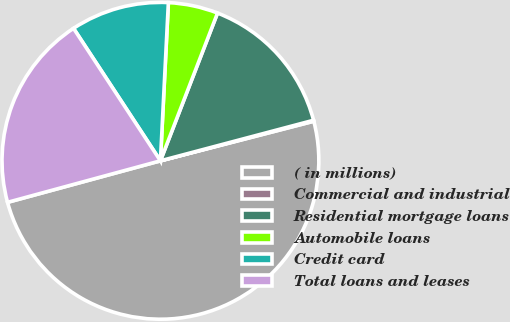<chart> <loc_0><loc_0><loc_500><loc_500><pie_chart><fcel>( in millions)<fcel>Commercial and industrial<fcel>Residential mortgage loans<fcel>Automobile loans<fcel>Credit card<fcel>Total loans and leases<nl><fcel>49.8%<fcel>0.1%<fcel>15.01%<fcel>5.07%<fcel>10.04%<fcel>19.98%<nl></chart> 